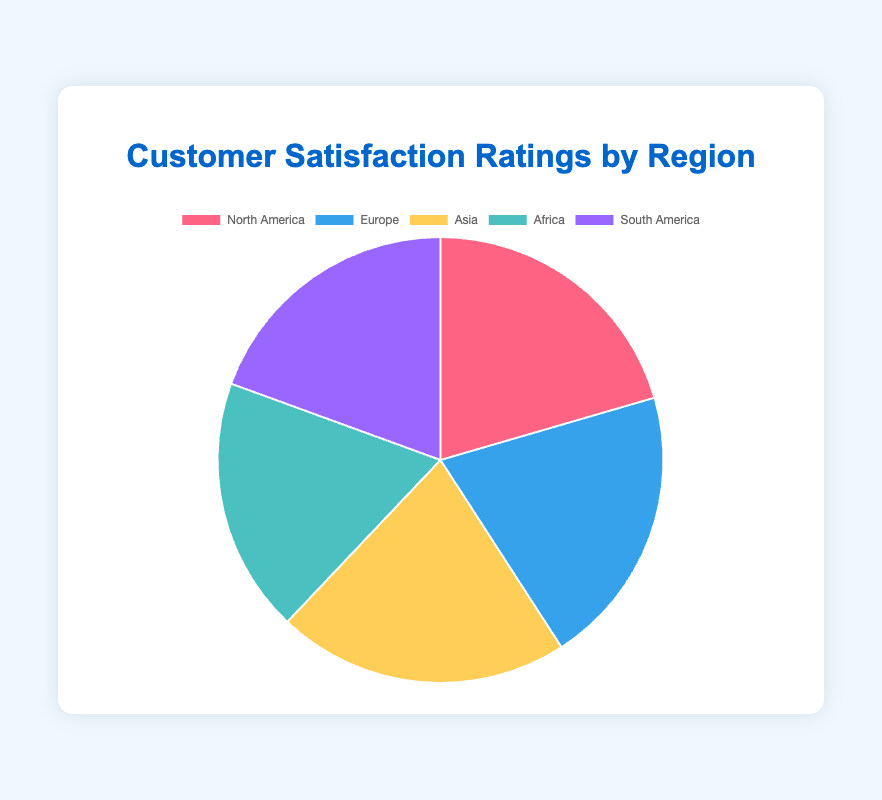Which region has the highest average customer satisfaction rating? The figure shows the average ratings by region. Asia has the highest rating with an average of 90.5.
Answer: Asia Which region has the lowest average customer satisfaction rating? The figure shows the average ratings by region. Africa has the lowest rating with an average of 79.
Answer: Africa How does the average rating in Europe compare to that in North America? The average rating in Europe is slightly higher than in North America. Europe has an average rating of 87, while North America has an average rating of 87.5.
Answer: North America has a slightly higher rating What is the difference between the highest and lowest average ratings among the regions? The highest average rating is in Asia (90.5), and the lowest is in Africa (79), so the difference is 90.5 - 79 = 11.5.
Answer: 11.5 What percentage of the total average ratings does South America contribute? Sum of the average ratings is approximately 424 (90.5 + 87.5 + 87 + 79 + 83). South America's average rating is 83. The contribution percentage is (83 / 424) * 100 ≈ 19.6%.
Answer: 19.6% Which regions have average ratings that are below the overall average rating? The overall average rating is calculated as the sum of all the regions' averages divided by the number of regions: (90.5 + 87.5 + 87 + 79 + 83) / 5 = 85.8. Regions with ratings below 85.8 are Africa (79) and South America (83).
Answer: Africa, South America What is the combined average rating for both North America and Europe? The combined average rating is the sum of the ratings for North America and Europe divided by 2: (87.5 + 87) / 2 = 87.25.
Answer: 87.25 Which region's average rating is closest to the overall average rating? The overall average rating is 85.8. The closest region is North America with an average of 87.5, which is 1.7 units away from the overall average.
Answer: North America What is the total sum of average ratings across all regions? Sum of the average ratings of all regions: 90.5 (Asia) + 87.5 (North America) + 87 (Europe) + 79 (Africa) + 83 (South America) = 427.
Answer: 427 